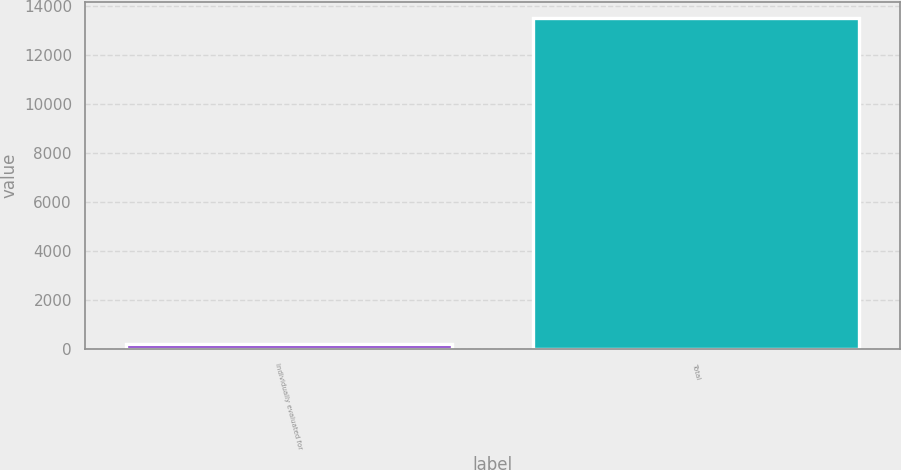Convert chart to OTSL. <chart><loc_0><loc_0><loc_500><loc_500><bar_chart><fcel>Individually evaluated for<fcel>Total<nl><fcel>206<fcel>13486<nl></chart> 